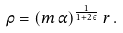<formula> <loc_0><loc_0><loc_500><loc_500>\rho = ( m \, \alpha ) ^ { \frac { 1 } { 1 + 2 \, \varepsilon } } \, r \, .</formula> 